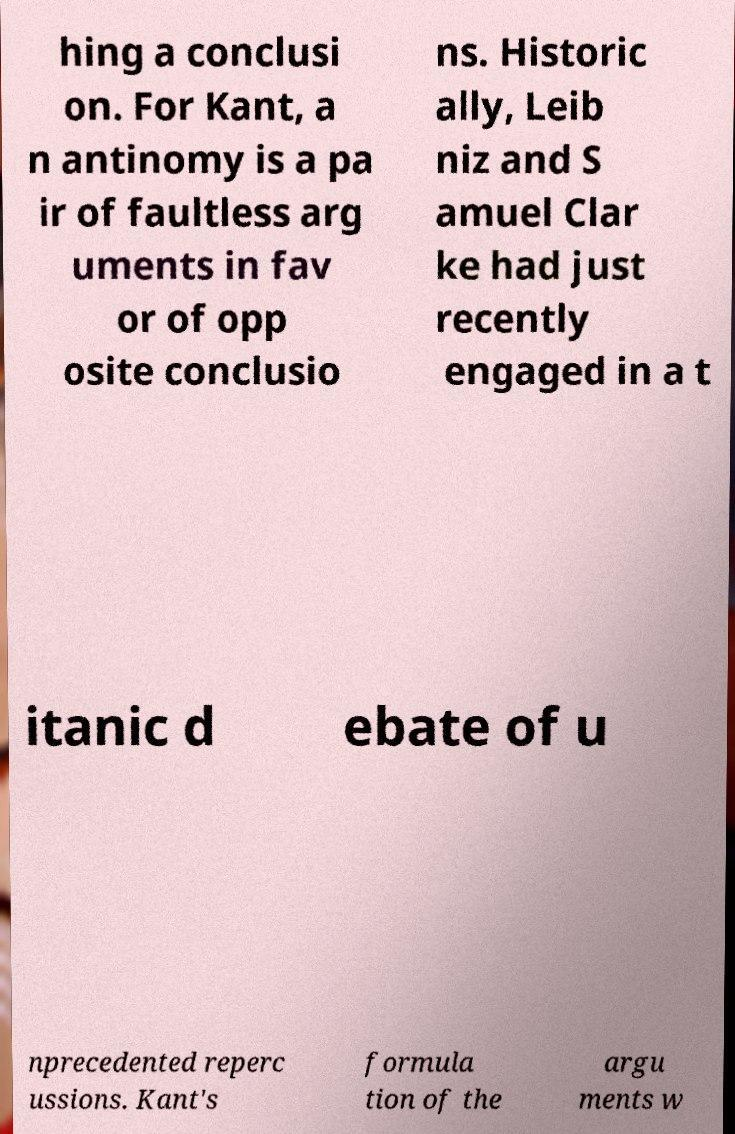I need the written content from this picture converted into text. Can you do that? hing a conclusi on. For Kant, a n antinomy is a pa ir of faultless arg uments in fav or of opp osite conclusio ns. Historic ally, Leib niz and S amuel Clar ke had just recently engaged in a t itanic d ebate of u nprecedented reperc ussions. Kant's formula tion of the argu ments w 